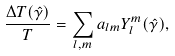<formula> <loc_0><loc_0><loc_500><loc_500>\frac { \Delta T ( \hat { \gamma } ) } { T } = \sum _ { l , m } a _ { l m } Y _ { l } ^ { m } ( \hat { \gamma } ) ,</formula> 